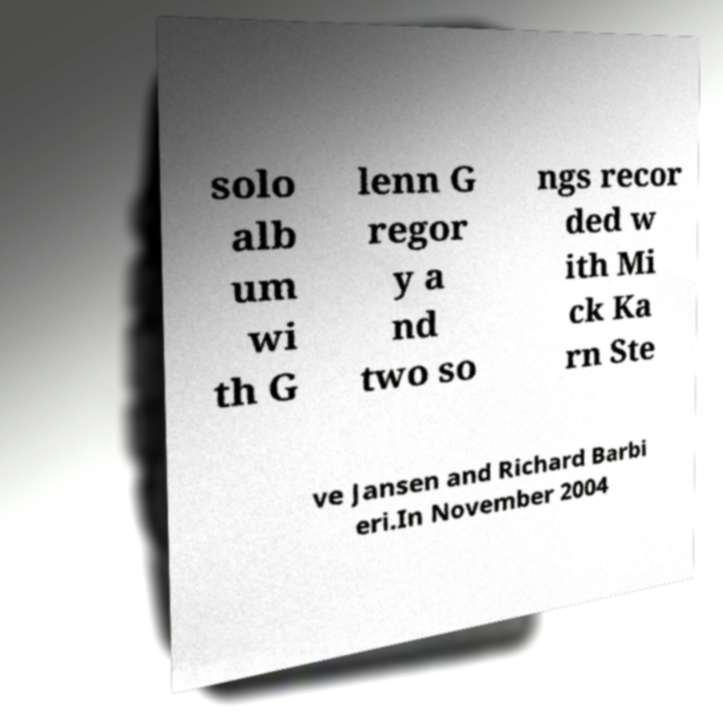For documentation purposes, I need the text within this image transcribed. Could you provide that? solo alb um wi th G lenn G regor y a nd two so ngs recor ded w ith Mi ck Ka rn Ste ve Jansen and Richard Barbi eri.In November 2004 